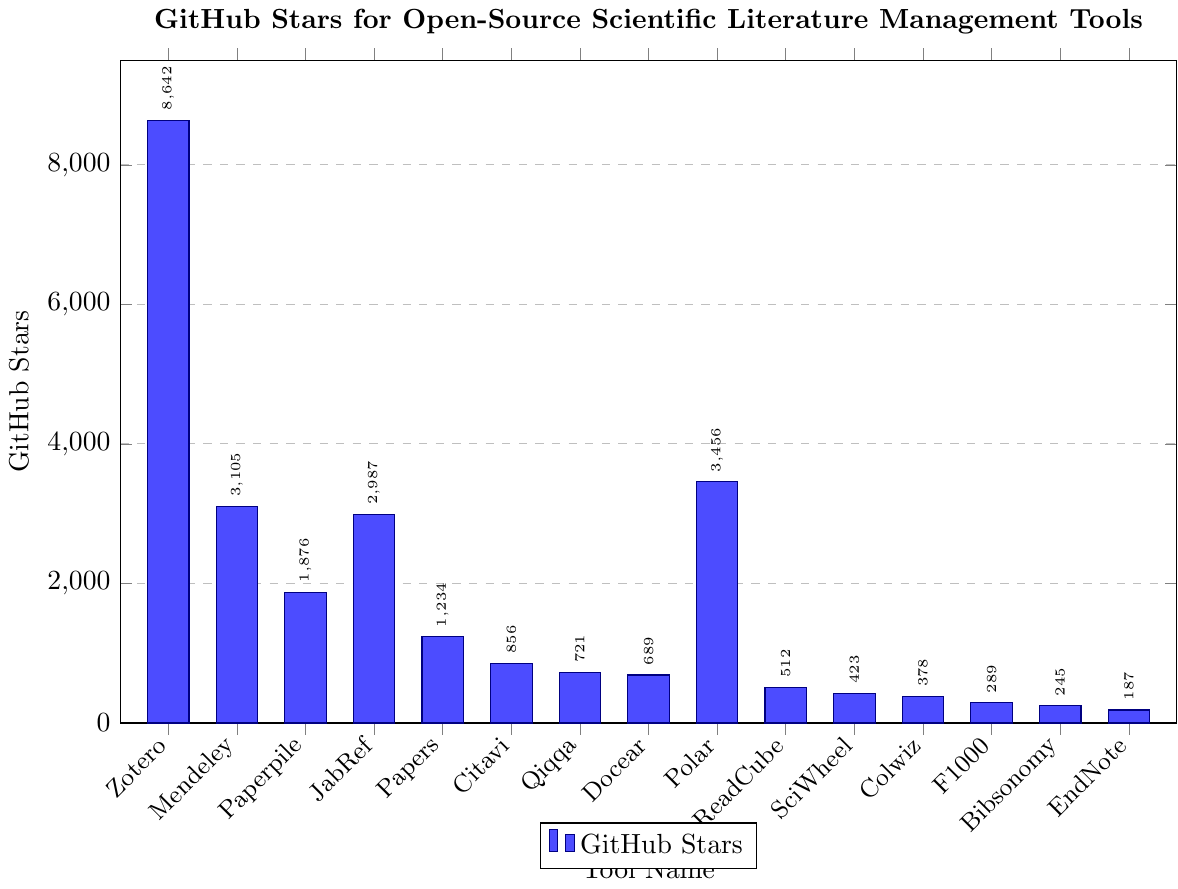Which tool has the highest number of GitHub stars? The bar chart shows the star count for each tool, and the tallest bar corresponds to Zotero, indicating it has the highest number of stars.
Answer: Zotero Which tool has the lowest number of GitHub stars? The bar chart shows the star count for each tool, and the shortest bar corresponds to EndNote Basic, indicating it has the lowest number of stars.
Answer: EndNote Basic How many more stars does Zotero have compared to Polar? From the bar chart, Zotero has 8642 stars, and Polar has 3456 stars. Subtract Polar's stars from Zotero's stars: 8642 - 3456 = 5186.
Answer: 5186 What is the total number of GitHub stars for Mendeley, JabRef, and Paperpile combined? Sum the number of stars for Mendeley (3105), JabRef (2987), and Paperpile (1876) from the chart: 3105 + 2987 + 1876 = 7968.
Answer: 7968 Which tools have more than 3000 GitHub stars? From the bar chart, the tools with more than 3000 stars are Zotero, Mendeley, and Polar.
Answer: Zotero, Mendeley, Polar What is the difference in GitHub stars between the tool with the highest and the tool with the lowest stars? The highest number of stars is Zotero with 8642, and the lowest is EndNote Basic with 187. Subtract the lowest from the highest: 8642 - 187 = 8455.
Answer: 8455 Are there any tools with a number of GitHub stars between 500 and 1000? Observing the bars in the chart, the tools that fall in this range are ReadCube (512) and Qiqqa (721).
Answer: ReadCube, Qiqqa What percentage of the total stars do Zotero and Polar combined represent? First, find the total number of stars for all tools: 8642 + 3105 + 1876 + 2987 + 1234 + 856 + 721 + 689 + 3456 + 512 + 423 + 378 + 289 + 245 + 187 = 26000. Then, find the combined stars for Zotero and Polar: 8642 + 3456 = 12098. Now calculate the percentage: (12098 / 26000) * 100 ≈ 46.53%.
Answer: 46.53% Which tool has nearly half as many stars as Mendeley? Mendeley has 3105 stars; half of this is approximately 1552.5. From the chart, Paperpile with 1876 stars is the closest to this value.
Answer: Paperpile What is the average number of GitHub stars for the tools listed? Sum the total stars for all tools: 8642 + 3105 + 1876 + 2987 + 1234 + 856 + 721 + 689 + 3456 + 512 + 423 + 378 + 289 + 245 + 187 = 26000. There are 15 tools, so the average is 26000 / 15 ≈ 1733.33.
Answer: 1733.33 